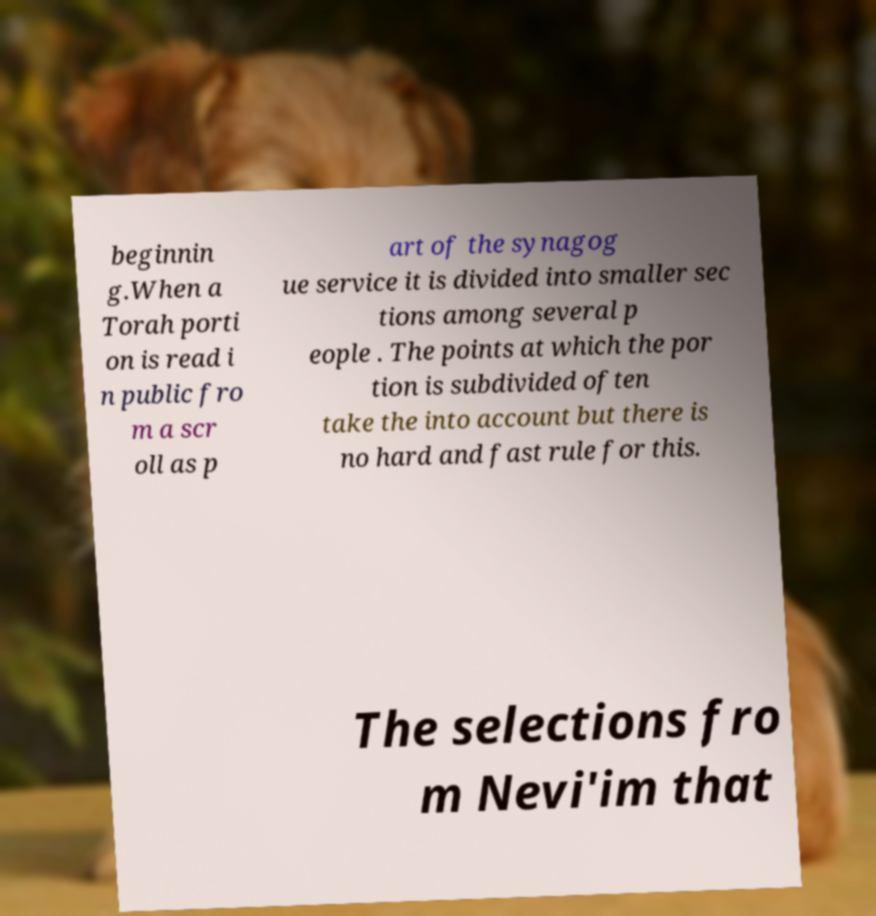Please identify and transcribe the text found in this image. beginnin g.When a Torah porti on is read i n public fro m a scr oll as p art of the synagog ue service it is divided into smaller sec tions among several p eople . The points at which the por tion is subdivided often take the into account but there is no hard and fast rule for this. The selections fro m Nevi'im that 